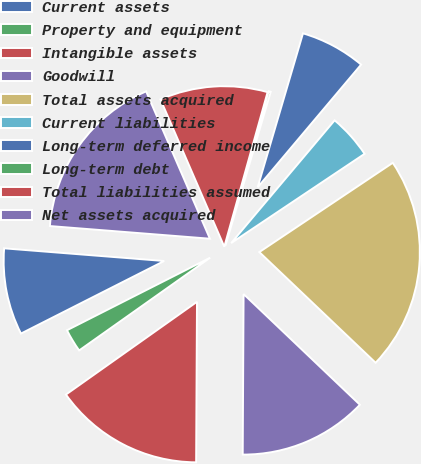<chart> <loc_0><loc_0><loc_500><loc_500><pie_chart><fcel>Current assets<fcel>Property and equipment<fcel>Intangible assets<fcel>Goodwill<fcel>Total assets acquired<fcel>Current liabilities<fcel>Long-term deferred income<fcel>Long-term debt<fcel>Total liabilities assumed<fcel>Net assets acquired<nl><fcel>8.72%<fcel>2.34%<fcel>15.11%<fcel>12.98%<fcel>21.49%<fcel>4.47%<fcel>6.59%<fcel>0.21%<fcel>10.85%<fcel>17.24%<nl></chart> 